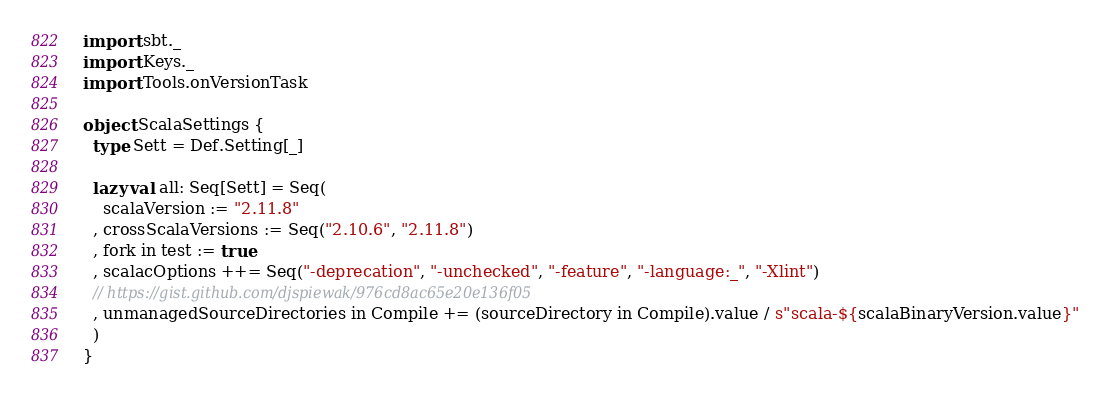<code> <loc_0><loc_0><loc_500><loc_500><_Scala_>import sbt._
import Keys._
import Tools.onVersionTask

object ScalaSettings {
  type Sett = Def.Setting[_]

  lazy val all: Seq[Sett] = Seq(
    scalaVersion := "2.11.8"
  , crossScalaVersions := Seq("2.10.6", "2.11.8")
  , fork in test := true
  , scalacOptions ++= Seq("-deprecation", "-unchecked", "-feature", "-language:_", "-Xlint")
  // https://gist.github.com/djspiewak/976cd8ac65e20e136f05
  , unmanagedSourceDirectories in Compile += (sourceDirectory in Compile).value / s"scala-${scalaBinaryVersion.value}"
  )
}
</code> 